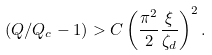<formula> <loc_0><loc_0><loc_500><loc_500>( Q / Q _ { c } - 1 ) > C \left ( \frac { \pi ^ { 2 } } { 2 } \frac { \xi } { \zeta _ { d } } \right ) ^ { 2 } .</formula> 